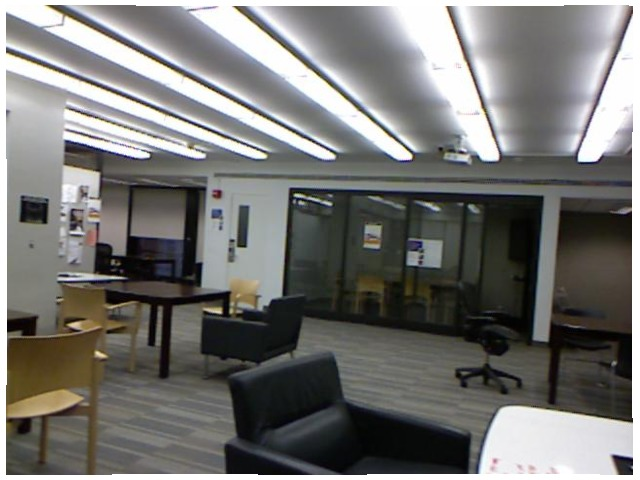<image>
Is the chair under the table? No. The chair is not positioned under the table. The vertical relationship between these objects is different. Is there a window on the floor? Yes. Looking at the image, I can see the window is positioned on top of the floor, with the floor providing support. Is the chair behind the table? Yes. From this viewpoint, the chair is positioned behind the table, with the table partially or fully occluding the chair. Where is the chair in relation to the chair? Is it to the right of the chair? Yes. From this viewpoint, the chair is positioned to the right side relative to the chair. 